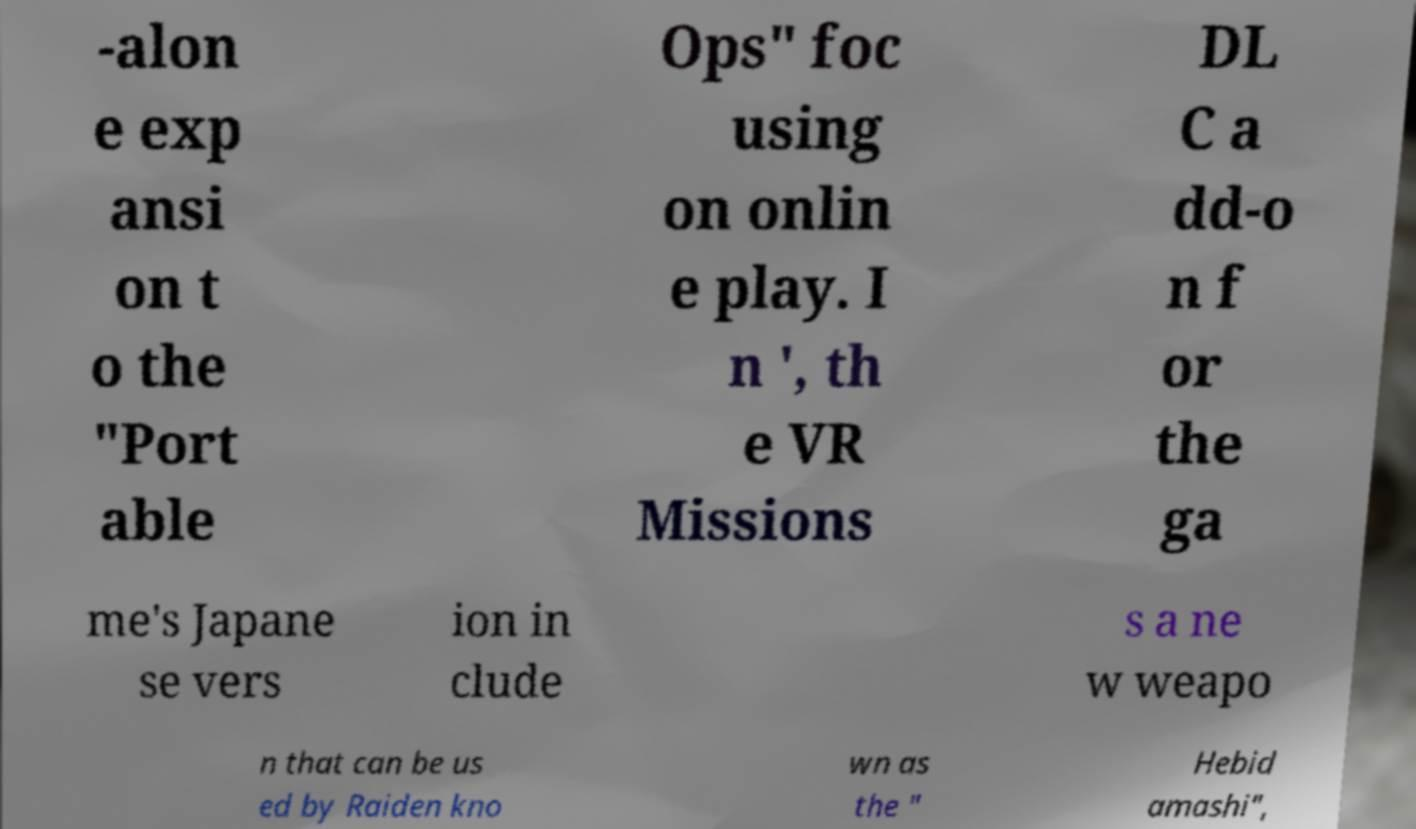What messages or text are displayed in this image? I need them in a readable, typed format. -alon e exp ansi on t o the "Port able Ops" foc using on onlin e play. I n ', th e VR Missions DL C a dd-o n f or the ga me's Japane se vers ion in clude s a ne w weapo n that can be us ed by Raiden kno wn as the " Hebid amashi", 